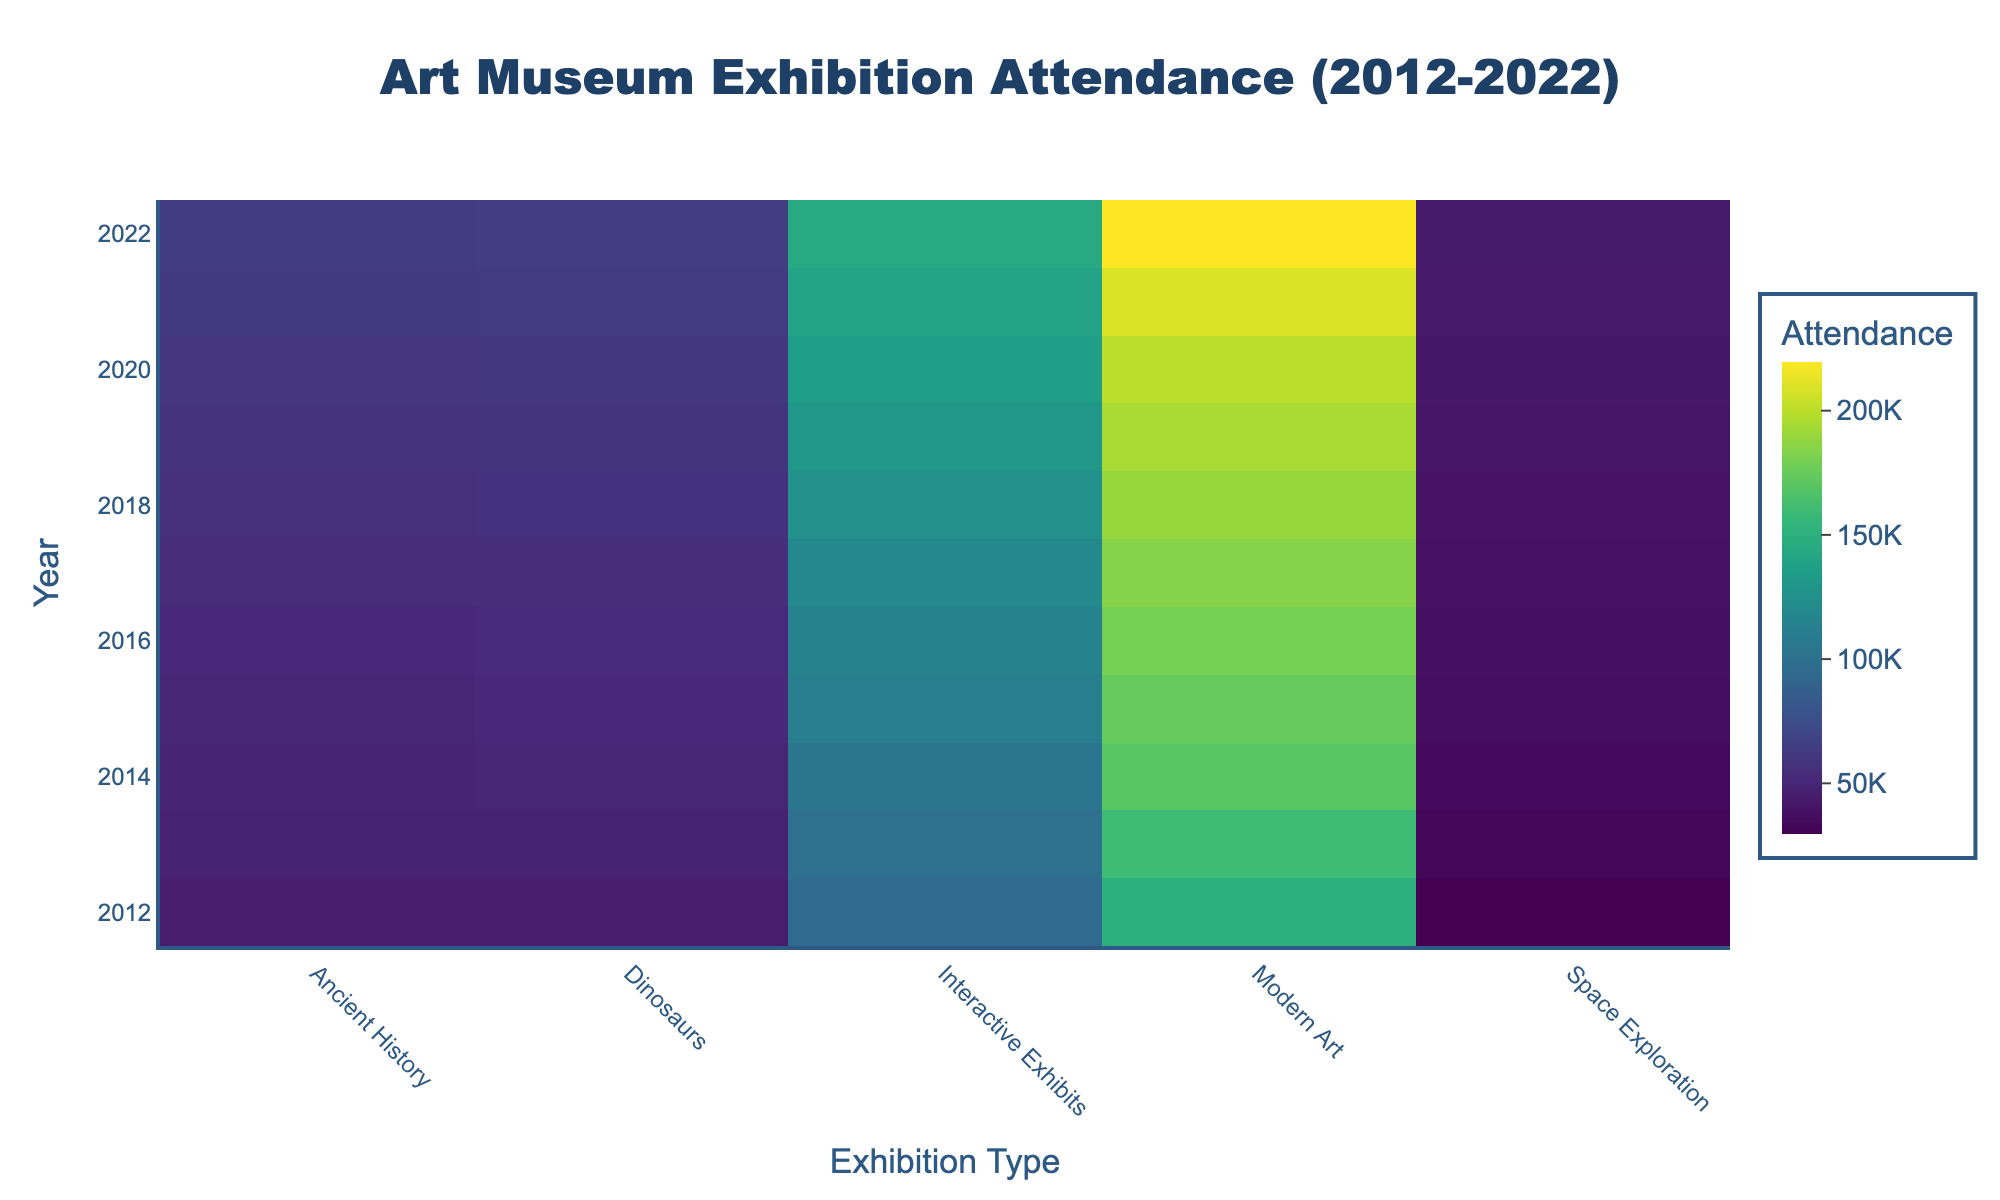what is the title of the figure? The title can be found at the top of the figure and is usually in larger, bold text. In this case, it reads "Art Museum Exhibition Attendance (2012-2022)".
Answer: Art Museum Exhibition Attendance (2012-2022) what year had the highest attendance for Ancient History exhibitions? Locate the Ancient History column on the x-axis and scan through the color intensity for each year on the y-axis. The highest attendance will correspond to the year with the most intense color.
Answer: 2022 compare the attendance for Modern Art exhibitions in 2015 and 2019. Identify the Modern Art column and check the colors for the years 2015 and 2019. The color intensity indicates the attendance values. 2019 has a darker color compared to 2015.
Answer: 2019 what is the color range used in the heatmap? The heatmap uses a color scale. The most intense colors usually represent the highest values while the lighter colors indicate lower values. The specific colors range from light yellow to dark purple.
Answer: light yellow to dark purple which year had the lowest attendance for Space Exploration exhibitions? Look at the Space Exploration column and scan through the color intensities for each year. The year with the lightest color represents the lowest attendance.
Answer: 2012 what is the average attendance for Dinosaurs exhibitions in 2012 and 2020? First, identify the attendance values for Dinosaurs in 2012 and 2020 by referencing the colors in the respective years. Dinosaurs in 2012 is ~45,000 and in 2020 is ~61,000. Average = (45,000 + 61,000) / 2
Answer: 53,000 based on the color intensity, which exhibition type had the most consistent attendance over the years? Scan each column's colors from top to bottom. The exhibition type where the colors change the least across years indicates the most consistent attendance. Interactive Exhibits maintain consistent color intensity throughout.
Answer: Interactive Exhibits how did the attendance for Interactive Exhibits change from 2012 to 2022? Locate the Interactive Exhibits column and compare the colors for 2012 and 2022. The colors get significantly darker from light yellow in 2012 to dark purple in 2022, indicating an increase in attendance.
Answer: Increased which museum exhibition had the sharpest increase in attendance between 2019 and 2020? Examine the change in color intensity from 2019 to 2020 for each column (exhibition type). The Space Exploration column shows a significant color change, indicating the sharpest increase.
Answer: Space Exploration 